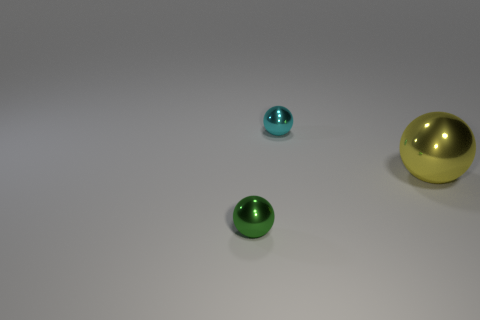How many big yellow things have the same material as the small cyan sphere?
Your answer should be compact. 1. What is the size of the cyan metal object that is the same shape as the big yellow object?
Your answer should be compact. Small. What color is the big thing that is the same shape as the small green shiny thing?
Keep it short and to the point. Yellow. There is a small metallic thing that is behind the sphere that is left of the tiny thing that is behind the large yellow ball; what shape is it?
Make the answer very short. Sphere. Are there an equal number of large yellow balls that are behind the big yellow thing and big yellow things behind the tiny cyan metallic object?
Offer a very short reply. Yes. What color is the other object that is the same size as the green thing?
Ensure brevity in your answer.  Cyan. How many small things are either yellow metal objects or cylinders?
Your answer should be compact. 0. Is the shape of the object that is behind the yellow metallic thing the same as the small metal object in front of the cyan shiny sphere?
Your response must be concise. Yes. How many objects are either balls that are on the left side of the yellow shiny thing or yellow balls?
Your response must be concise. 3. Is the yellow shiny ball the same size as the cyan metallic ball?
Provide a succinct answer. No. 